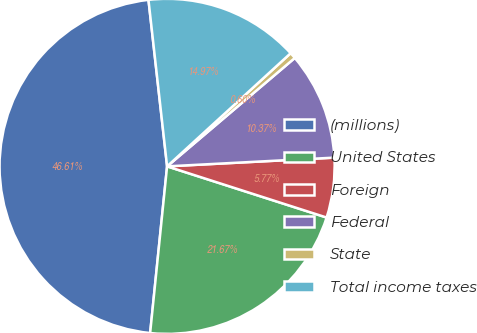<chart> <loc_0><loc_0><loc_500><loc_500><pie_chart><fcel>(millions)<fcel>United States<fcel>Foreign<fcel>Federal<fcel>State<fcel>Total income taxes<nl><fcel>46.61%<fcel>21.67%<fcel>5.77%<fcel>10.37%<fcel>0.6%<fcel>14.97%<nl></chart> 